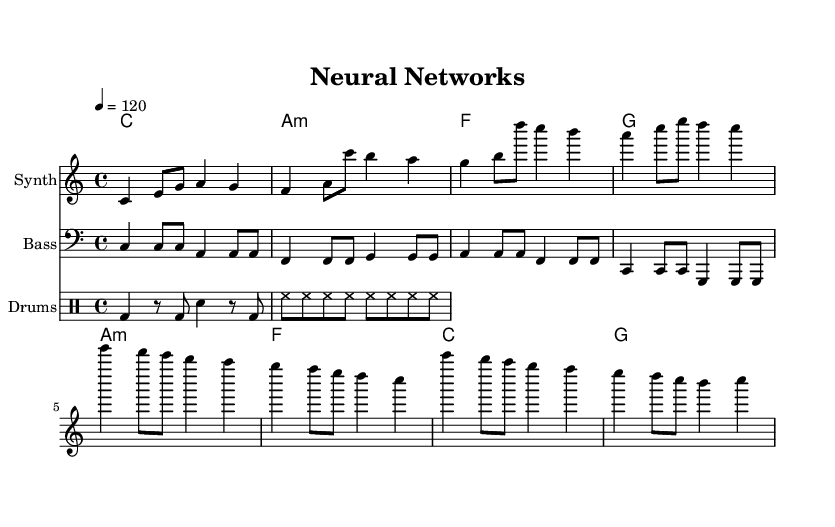What is the key signature of this music? The key signature indicated at the beginning of the score is C major, which has no sharps or flats.
Answer: C major What is the time signature of the piece? The time signature is shown at the beginning of the score as 4/4, indicating four beats per measure and a quarter note receives one beat.
Answer: 4/4 What is the tempo marking for the song? The tempo marking is found at the beginning of the score and is indicated as 4 = 120, meaning that there are 120 beats per minute.
Answer: 120 How many measures are there in the chorus? By counting the measures in the chorus section, there are a total of four measures, as indicated by the bar lines in that section of the sheet music.
Answer: 4 Which instrument plays the melody? The instrument provided for the melody is labeled in the score as "Synth," which denotes the specific role of the melody in the arrangement.
Answer: Synth What type of harmony is used in the verse? The harmony in the verse is based on the chord progression of C major, A minor, F major, and G major, which are typical for pop music.
Answer: C, A minor, F, G How does the lyric "Neural networks" reflect the theme of the song? The phrase "Neural networks" in the chorus encapsulates the song's theme focused on artificial intelligence and machine learning, signaling the core concept of technology.
Answer: Technology 